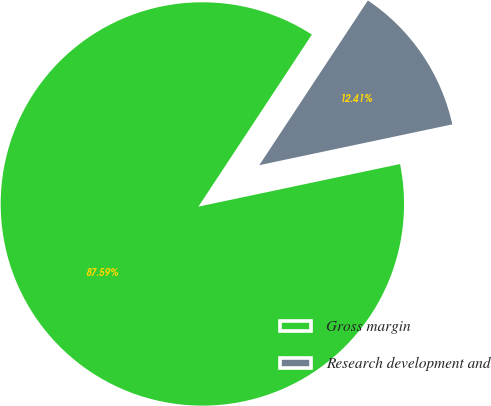Convert chart to OTSL. <chart><loc_0><loc_0><loc_500><loc_500><pie_chart><fcel>Gross margin<fcel>Research development and<nl><fcel>87.59%<fcel>12.41%<nl></chart> 